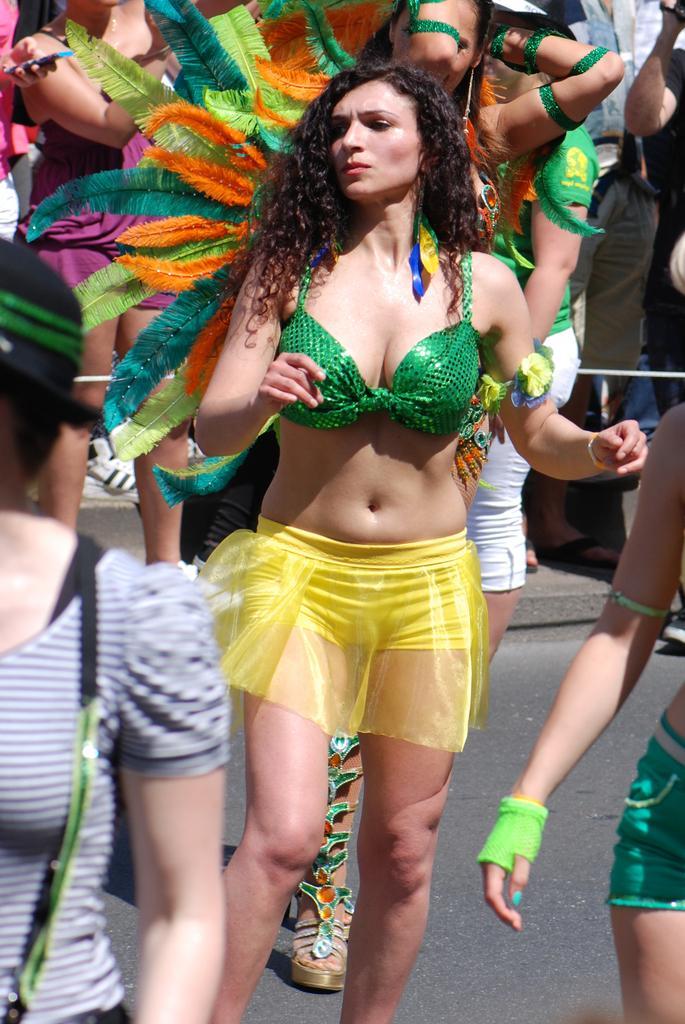How would you summarize this image in a sentence or two? In this image I can see a woman is there, behind her there are different colors feathers. 